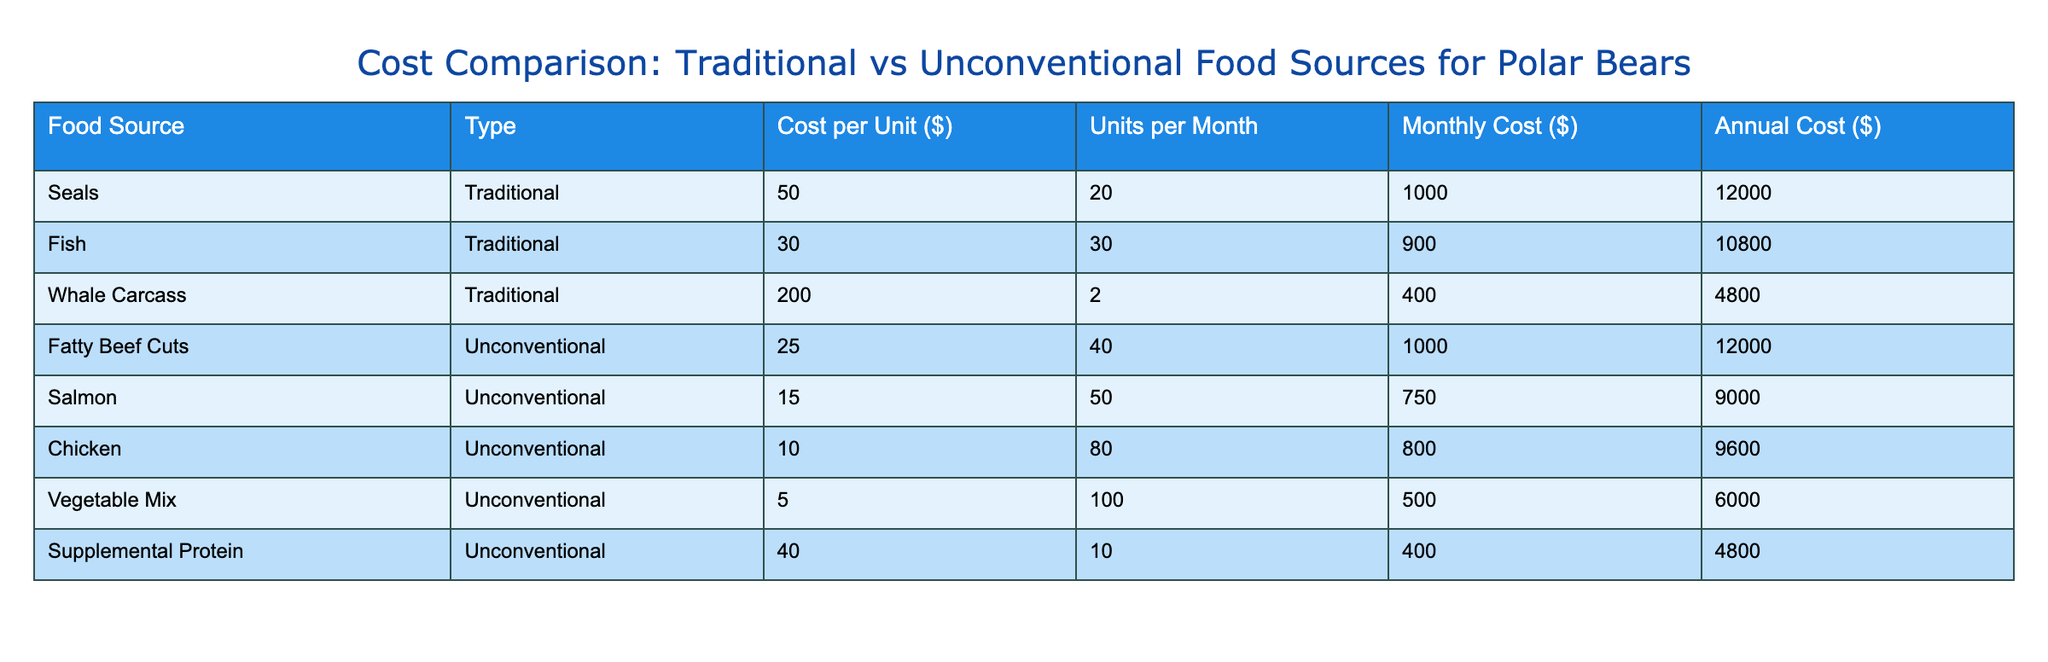What is the total annual cost for traditional food sources? To find the total annual cost for traditional food sources, we need to sum the "Annual Cost ($)" for each traditional food source. The value for seals is 12000, for fish is 10800, and for whale carcass is 4800. Adding these: 12000 + 10800 + 4800 = 27600.
Answer: 27600 Which unconventional food source has the lowest annual cost? Looking at the "Annual Cost ($)" for each unconventional food source: Fatty Beef Cuts is 12000, Salmon is 9000, Chicken is 9600, Vegetable Mix is 6000, and Supplemental Protein is 4800. The lowest value is 4800 for Supplemental Protein.
Answer: Supplemental Protein What is the monthly cost of seals compared to fish? The monthly cost of seals is 1000, while the monthly cost of fish is 900. To compare, we look at the values directly: seals (1000) is greater than fish (900).
Answer: Seals cost more than fish What is the average cost per unit for unconventional food sources? To find this average, we list the cost per unit for each unconventional food source: Fatty Beef Cuts is 25, Salmon is 15, Chicken is 10, Vegetable Mix is 5, and Supplemental Protein is 40. Adding these gives 25 + 15 + 10 + 5 + 40 = 95. There are 5 sources, so dividing the total by 5 gives 95 / 5 = 19.
Answer: 19 Is the total annual cost for all unconventional food sources less than that for traditional food sources? The total annual cost for unconventional sources is determined by summing their annual costs: 12000 + 9000 + 9600 + 6000 + 4800 = 43200. The total for traditional sources is 27600. Since 43200 is greater than 27600, the answer is no.
Answer: No What is the difference in monthly cost between the most expensive traditional food source and the least expensive unconventional food source? The most expensive traditional food source is whale carcass with a monthly cost of 400, and the least expensive unconventional source is vegetable mix with a monthly cost of 500. To find the difference, we calculate 500 - 400 = 100.
Answer: 100 Which food source has the highest cost per unit? Examining the "Cost per Unit ($)" values: Seals is 50, Fish is 30, Whale Carcass is 200, Fatty Beef Cuts is 25, Salmon is 15, Chicken is 10, Vegetable Mix is 5, and Supplemental Protein is 40. The highest value is 200 for Whale Carcass.
Answer: Whale Carcass How much does the annual cost of fish contribute to the total annual cost of traditional food sources? The annual cost of fish is 10800. We previously calculated the total annual cost for traditional food sources as 27600. Therefore, the contribution is 10800 out of 27600.
Answer: 10800 Which food source combination would provide the highest monthly cost if taken as one unit of each type? The highest monthly costs among food sources are seals (1000), fish (900), and the highest unconventional is fatty beef cuts (1000). Adding those gives 1000 + 900 + 1000 = 2900.
Answer: 2900 